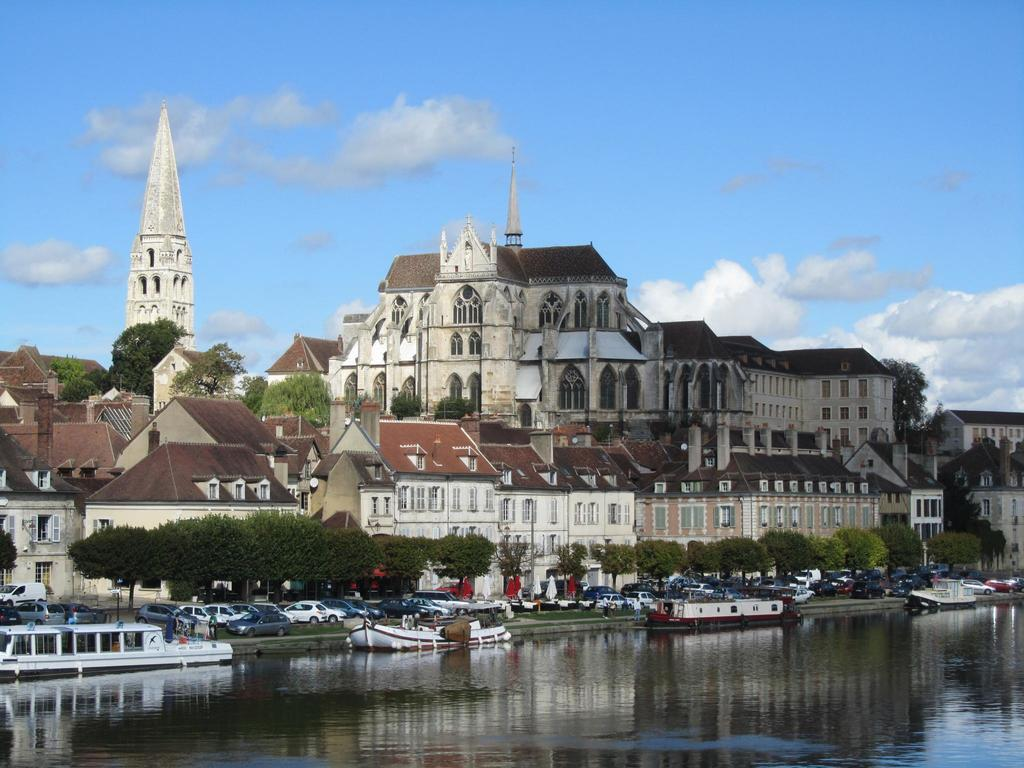What is the primary element visible in the image? There is water in the image. What types of transportation can be seen in the image? There are boats and vehicles in the image. What natural elements are present in the image? There are trees in the image. What man-made structures are visible in the image? There are buildings in the image. What architectural feature can be seen in the buildings? There are windows in the buildings. What can be seen in the background of the image? There are clouds and the sky visible in the background of the image. What type of cork can be seen in the image? There is no cork present in the image. 